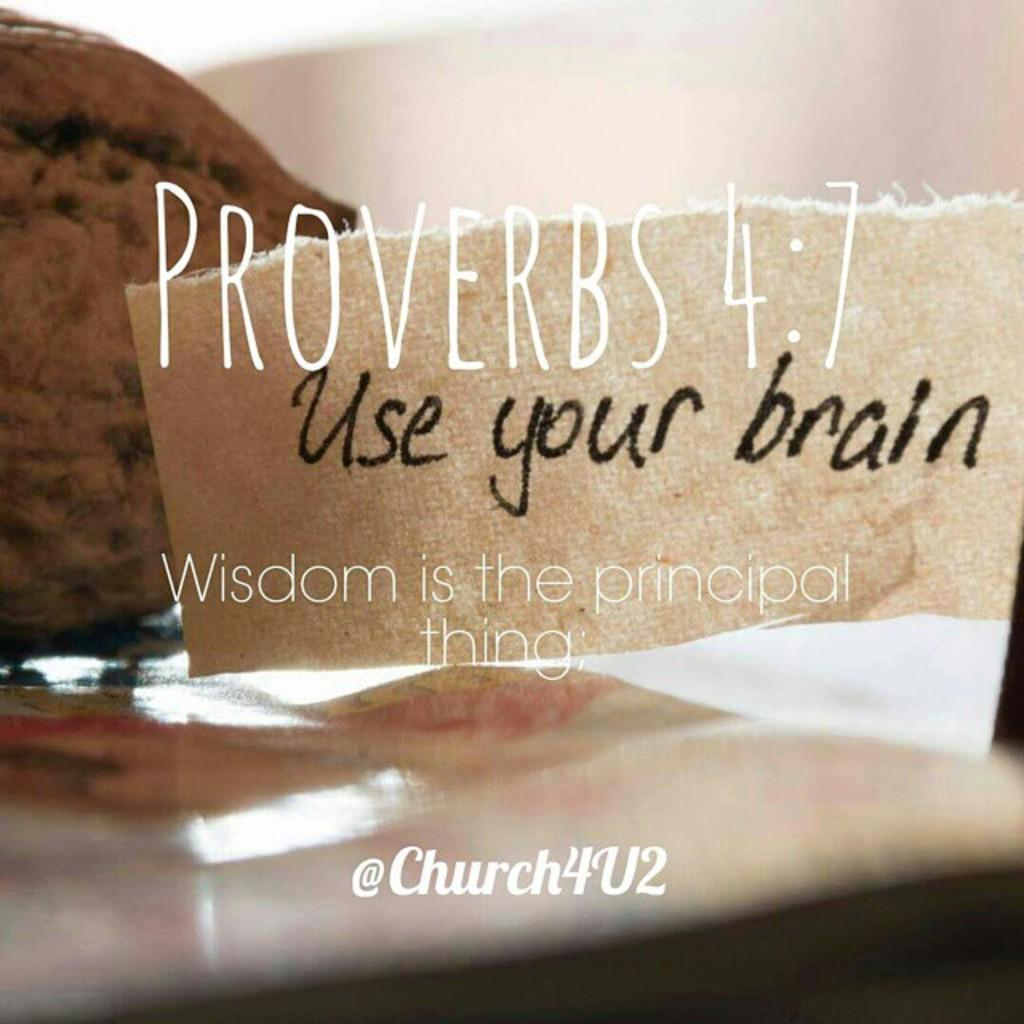What is featured on the poster in the image? There is a poster in the image, and it has papers on it. What else can be seen on the poster besides the papers? There is text on the poster. How many tickets are visible on the poster in the image? There are no tickets present on the poster in the image. What type of liquid is being poured on the poster in the image? There is no liquid being poured on the poster in the image. 